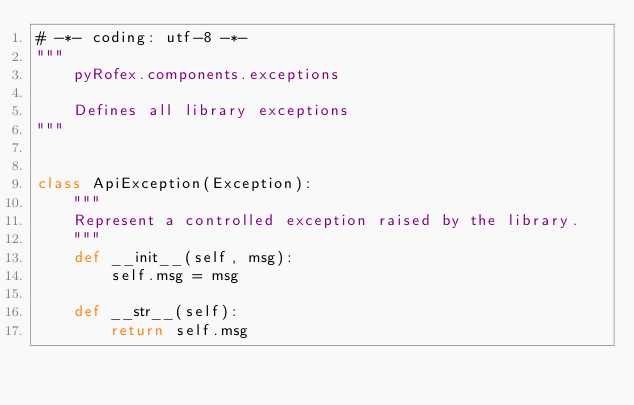Convert code to text. <code><loc_0><loc_0><loc_500><loc_500><_Python_># -*- coding: utf-8 -*-
"""
    pyRofex.components.exceptions

    Defines all library exceptions
"""


class ApiException(Exception):
    """
    Represent a controlled exception raised by the library.
    """
    def __init__(self, msg):
        self.msg = msg

    def __str__(self):
        return self.msg

</code> 